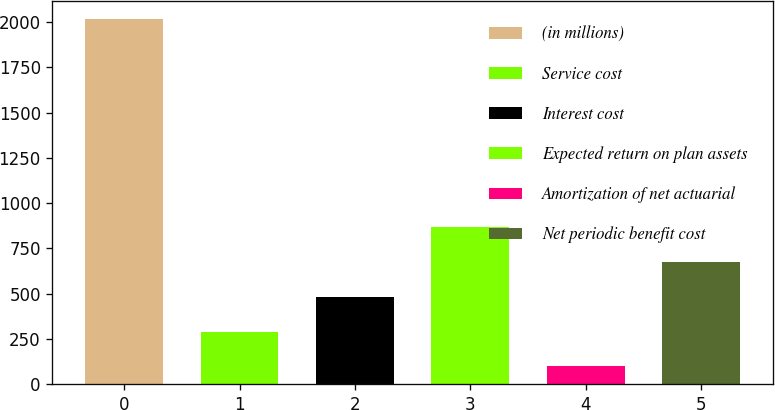<chart> <loc_0><loc_0><loc_500><loc_500><bar_chart><fcel>(in millions)<fcel>Service cost<fcel>Interest cost<fcel>Expected return on plan assets<fcel>Amortization of net actuarial<fcel>Net periodic benefit cost<nl><fcel>2016<fcel>289.8<fcel>481.6<fcel>865.2<fcel>98<fcel>673.4<nl></chart> 